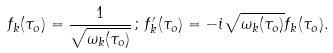<formula> <loc_0><loc_0><loc_500><loc_500>f _ { k } ( \tau _ { o } ) = \frac { 1 } { \sqrt { \omega _ { k } ( \tau _ { o } ) } } \, ; \, f _ { k } ^ { \prime } ( \tau _ { o } ) = - i \sqrt { \omega _ { k } ( \tau _ { o } ) } f _ { k } ( \tau _ { o } ) .</formula> 